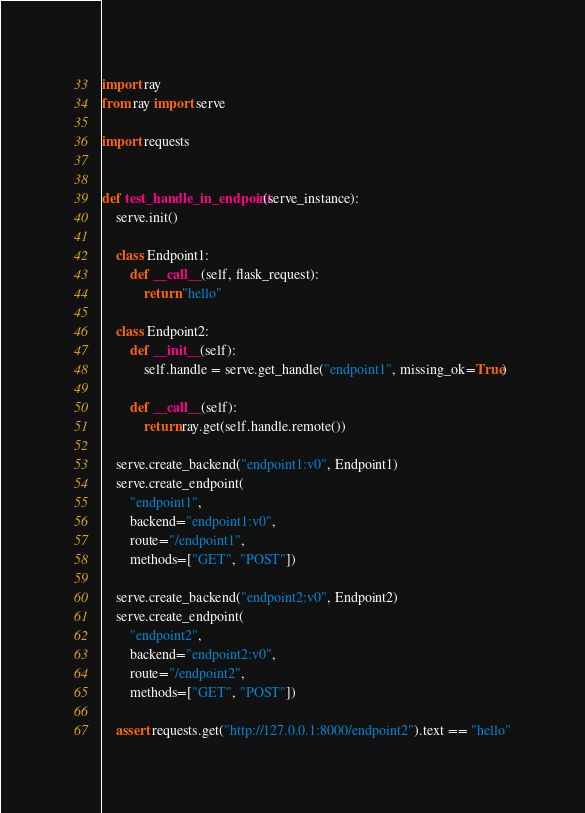<code> <loc_0><loc_0><loc_500><loc_500><_Python_>import ray
from ray import serve

import requests


def test_handle_in_endpoint(serve_instance):
    serve.init()

    class Endpoint1:
        def __call__(self, flask_request):
            return "hello"

    class Endpoint2:
        def __init__(self):
            self.handle = serve.get_handle("endpoint1", missing_ok=True)

        def __call__(self):
            return ray.get(self.handle.remote())

    serve.create_backend("endpoint1:v0", Endpoint1)
    serve.create_endpoint(
        "endpoint1",
        backend="endpoint1:v0",
        route="/endpoint1",
        methods=["GET", "POST"])

    serve.create_backend("endpoint2:v0", Endpoint2)
    serve.create_endpoint(
        "endpoint2",
        backend="endpoint2:v0",
        route="/endpoint2",
        methods=["GET", "POST"])

    assert requests.get("http://127.0.0.1:8000/endpoint2").text == "hello"
</code> 